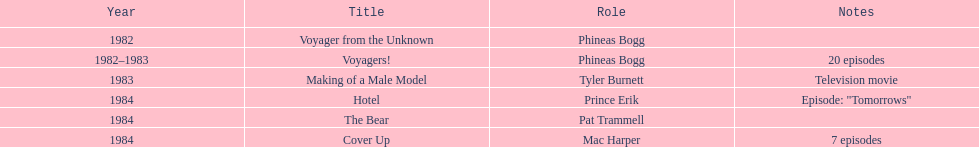In what year did he portray mac harper and pat trammell? 1984. 